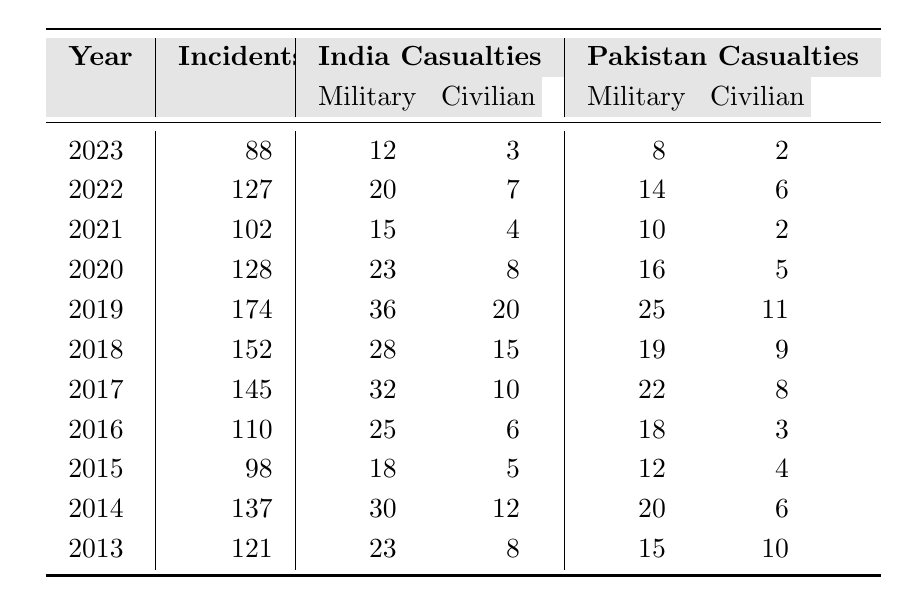What was the highest number of cross-border skirmish incidents over the last decade? The data shows that the highest number of incidents occurred in 2019, with a total of 174 incidents.
Answer: 174 Which year had the least military casualties for India? Looking at the table, the year with the least military casualties for India is 2021, with 15 casualties.
Answer: 15 How many total casualties did India suffer across the years in the table? By summing up India's military and civilian casualties from each year, we find that the total is (23 + 30 + 18 + 25 + 32 + 28 + 36 + 23 + 15 + 20 + 12) + (8 + 12 + 5 + 6 + 10 + 15 + 20 + 8 + 4 + 7 + 3) = 278 +  94 = 372 total casualties.
Answer: 372 What percentage of incidents in 2018 resulted in civilian casualties for India? In 2018, there were 152 incidents and 15 civilian casualties in India. To calculate the percentage, we use the formula (15/152) * 100, which equals approximately 9.87%.
Answer: 9.87% Did Pakistan have more military or civilian casualties in 2020? In 2020, Pakistan had 16 military casualties and 5 civilian casualties. Since 16 > 5, Pakistan had more military casualties that year.
Answer: Yes What was the trend in the number of incidents from 2013 to 2023? By analyzing the table, the trend shows an initial increase in incidents from 121 in 2013 to 174 in 2019, followed by a decrease to 88 in 2023.
Answer: Increasing then decreasing What is the average number of incidents per year over the last decade? To calculate the average, sum the number of incidents from all 11 years (121 + 137 + 98 + 110 + 145 + 152 + 174 + 128 + 102 + 127 + 88) = 1,433 and then divide by 11, which gets approximately 130.27.
Answer: 130.27 In which year did India suffer the highest civilian casualties? In 2019, India suffered the highest civilian casualties at 20.
Answer: 20 What is the difference in total military casualties between India and Pakistan in the most recent year, 2023? In 2023, India had 12 military casualties, while Pakistan had 8. The difference is 12 - 8 = 4.
Answer: 4 For which year was the ratio of civilian to military casualties for India the lowest? By calculating the civilian to military casualty ratios for each year, we find that 2021 has the lowest ratio with 4 civilian casualties to 15 military casualties, which simplifies to 0.27.
Answer: 2021 